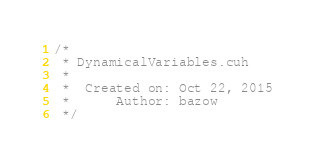<code> <loc_0><loc_0><loc_500><loc_500><_Cuda_>/*
 * DynamicalVariables.cuh
 *
 *  Created on: Oct 22, 2015
 *      Author: bazow
 */
</code> 